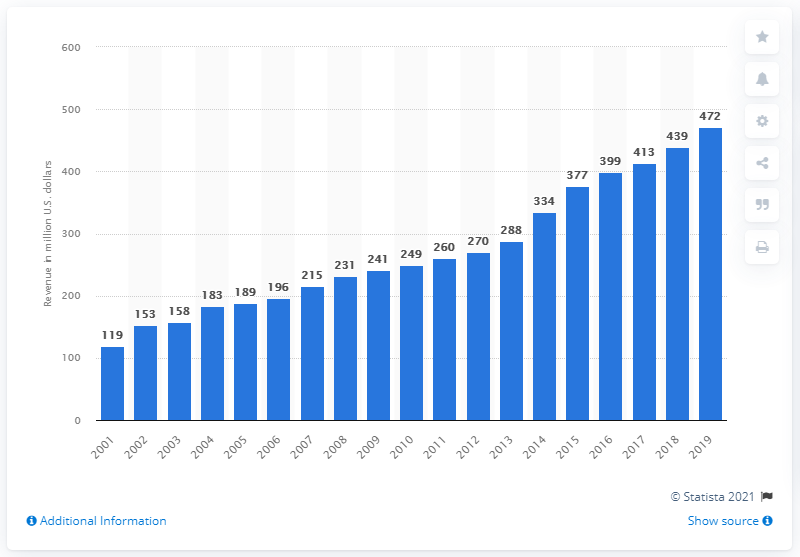List a handful of essential elements in this visual. In 2019, the revenue of the Seattle Seahawks was 472 million dollars. 